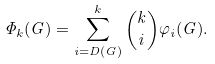<formula> <loc_0><loc_0><loc_500><loc_500>\Phi _ { k } ( G ) = \sum _ { i = D ( G ) } ^ { k } { k \choose i } \varphi _ { i } ( G ) .</formula> 